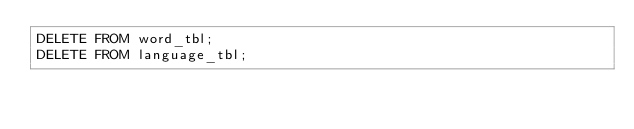<code> <loc_0><loc_0><loc_500><loc_500><_SQL_>DELETE FROM word_tbl;
DELETE FROM language_tbl;
</code> 